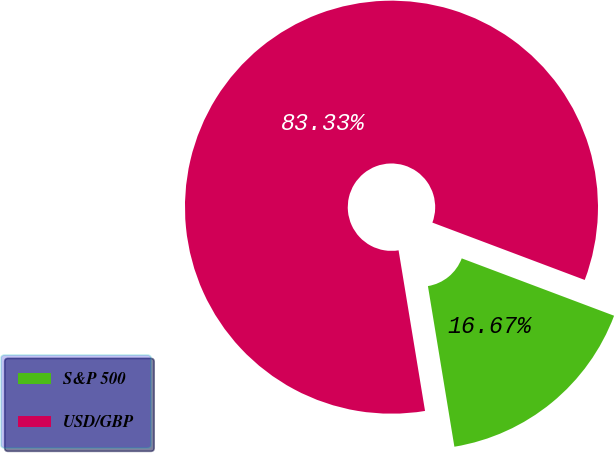<chart> <loc_0><loc_0><loc_500><loc_500><pie_chart><fcel>S&P 500<fcel>USD/GBP<nl><fcel>16.67%<fcel>83.33%<nl></chart> 